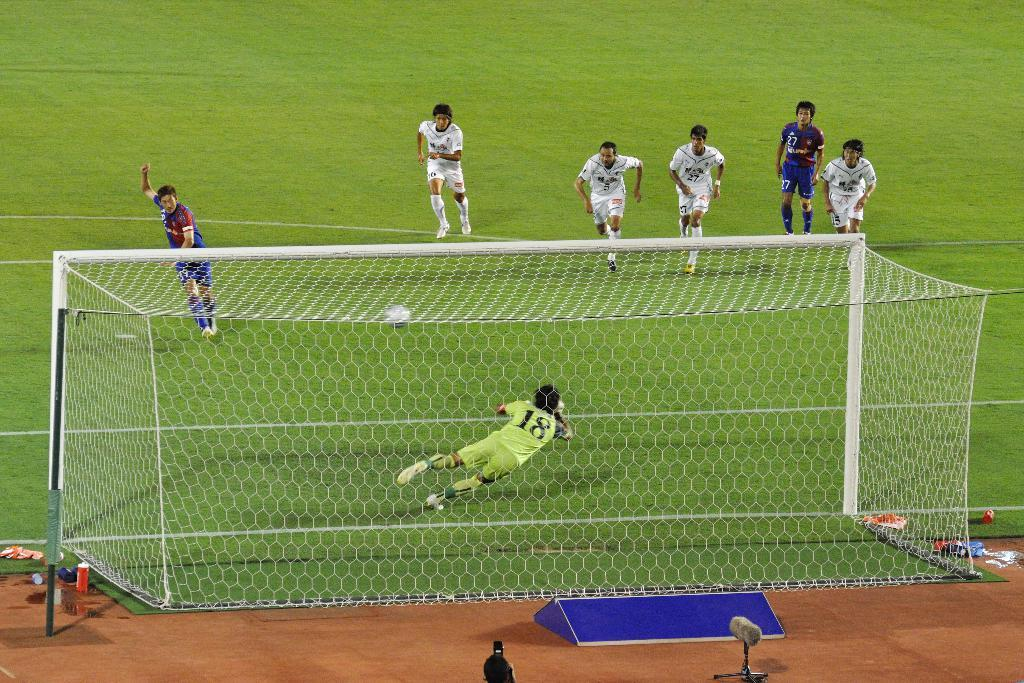<image>
Provide a brief description of the given image. A soccer goalie with jersey 18 is diving for the ball. 